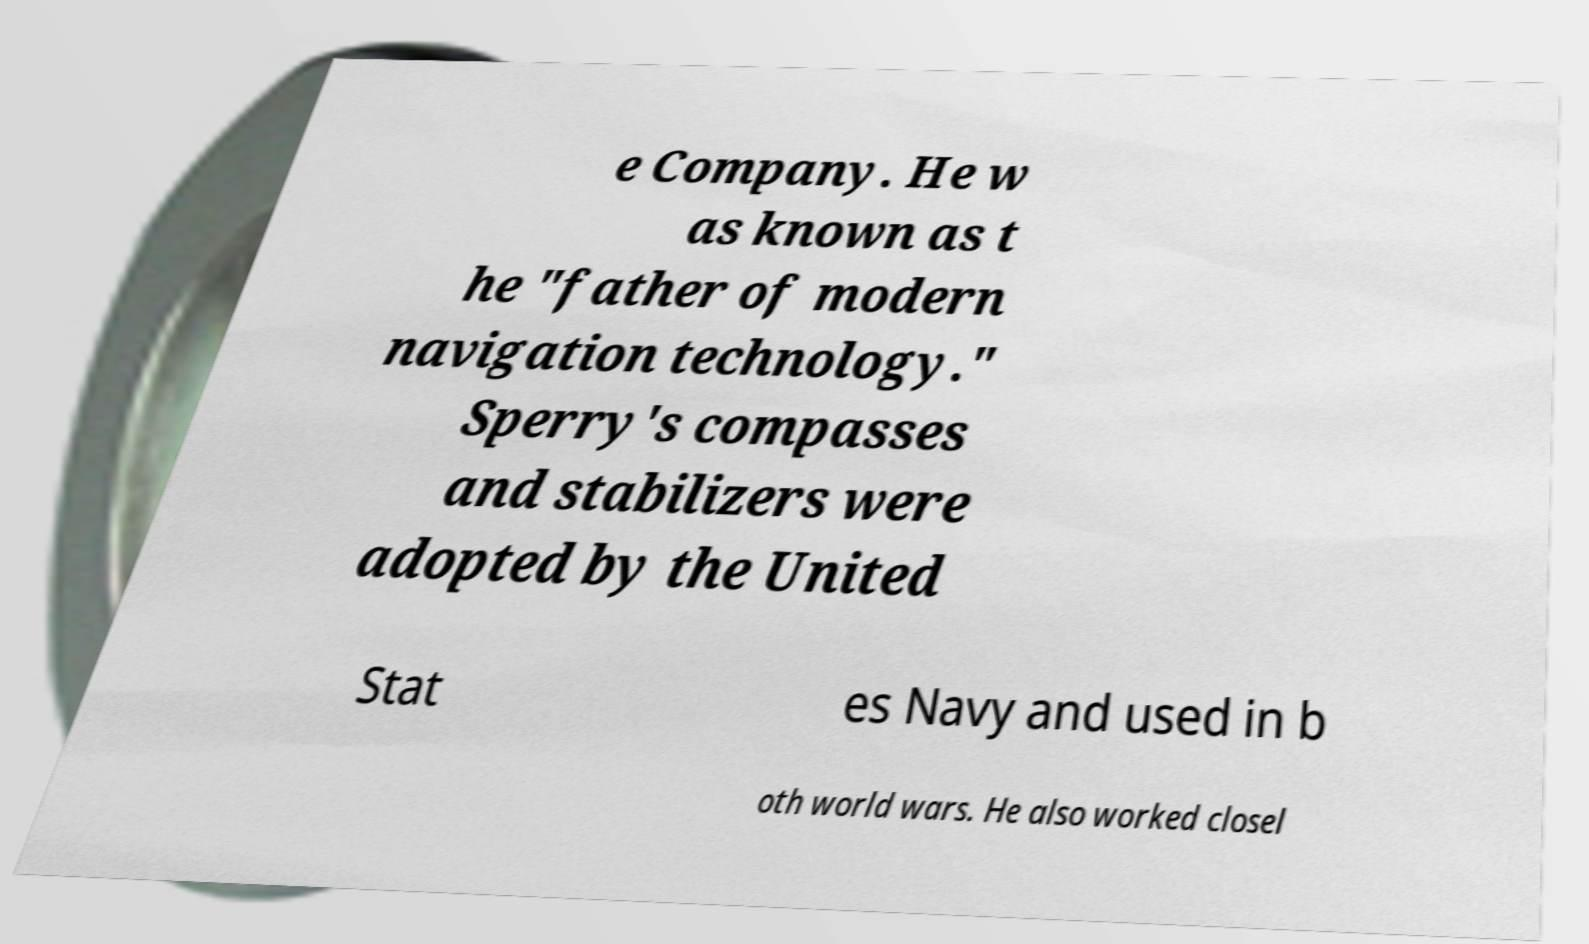There's text embedded in this image that I need extracted. Can you transcribe it verbatim? e Company. He w as known as t he "father of modern navigation technology." Sperry's compasses and stabilizers were adopted by the United Stat es Navy and used in b oth world wars. He also worked closel 